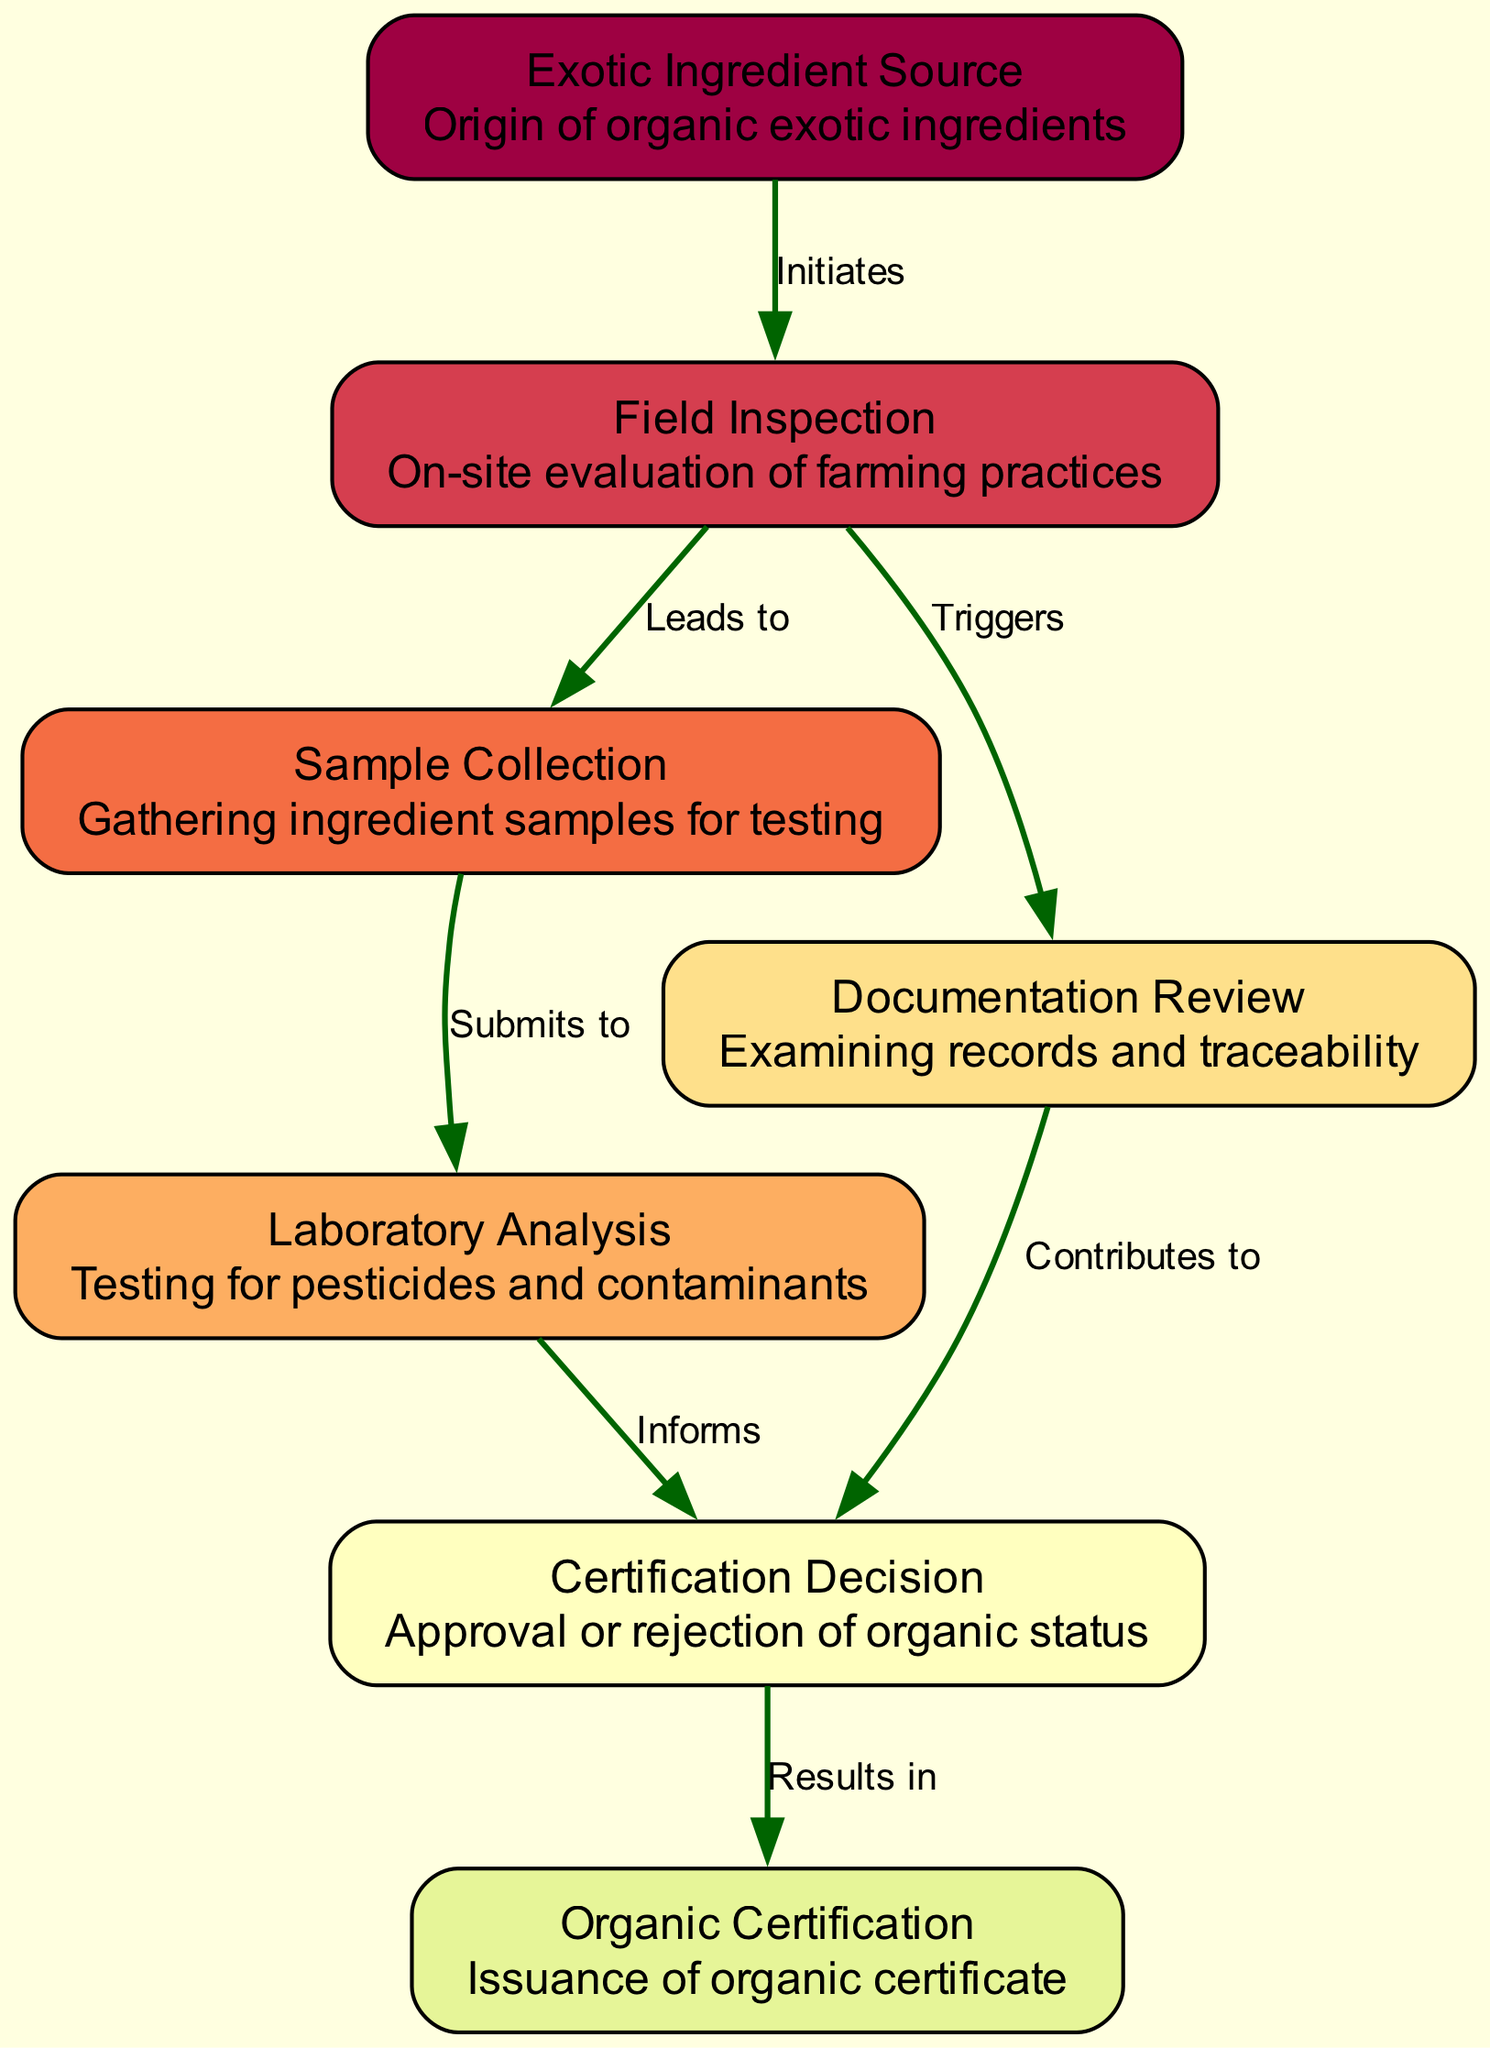What is the first step in the organic certification process? The first step is the "Exotic Ingredient Source". According to the diagram, this node initiates the certification process.
Answer: Exotic Ingredient Source How many nodes are present in the diagram? By counting the listed nodes in the data, there are seven nodes total in the diagram.
Answer: 7 What does "Field Inspection" lead to? "Field Inspection" leads to "Sample Collection." This directional edge from node 2 to node 3 signifies the flow of the process.
Answer: Sample Collection What occurs after "Laboratory Analysis"? After "Laboratory Analysis," the next step is the "Certification Decision." This is indicated by the directed edge flowing from node 4 to node 6.
Answer: Certification Decision Which step triggers the "Documentation Review"? The "Field Inspection" step triggers the "Documentation Review." The edge from node 2 to node 5 marks this relationship in the diagram.
Answer: Documentation Review What results in the issuance of an organic certificate? The issuance of an organic certificate results from the "Certification Decision." This relationship is shown with an edge from node 6 to node 7.
Answer: Certification Decision What type of information does "Laboratory Analysis" provide? "Laboratory Analysis" informs the "Certification Decision." The directional connection from node 4 to node 6 indicates how it contributes information for further decisions.
Answer: Informs What is the final outcome of the organic certification process? The final outcome is the "Organic Certification," represented by the last node in the flow of the diagram, which follows the certification decision.
Answer: Organic Certification Which two steps contribute to the "Certification Decision"? Both "Laboratory Analysis" and "Documentation Review" contribute to the "Certification Decision," as indicated by the edges connecting nodes 4 and 5 to node 6.
Answer: Laboratory Analysis and Documentation Review 